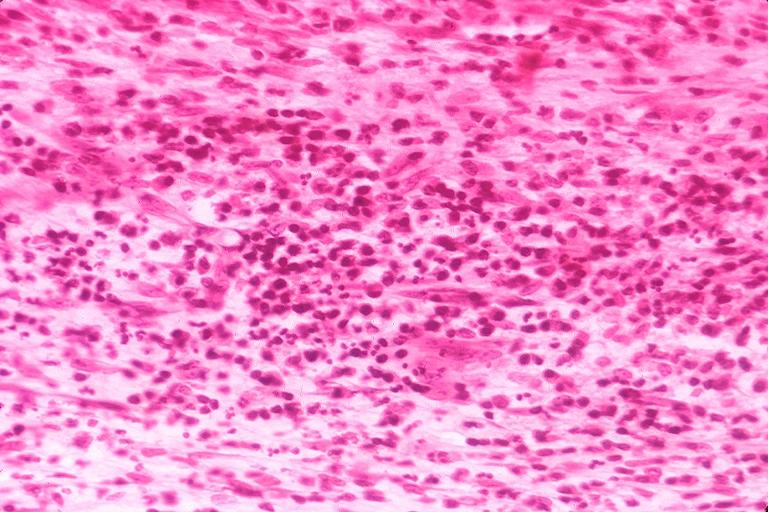does metastatic carcinoid show chronic pulpitis?
Answer the question using a single word or phrase. No 